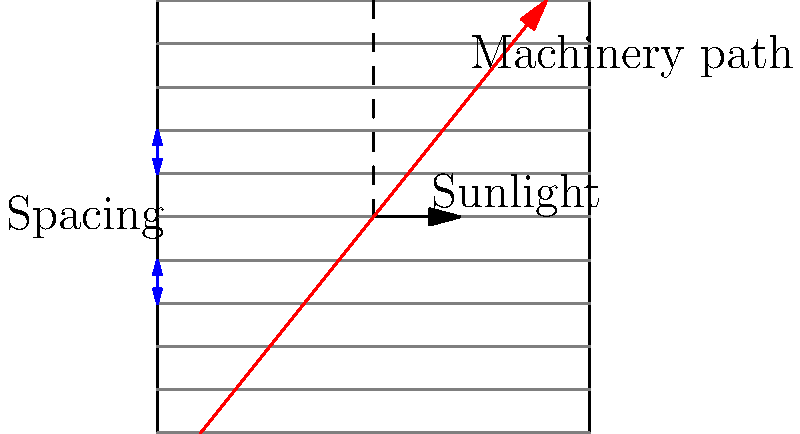In a large-scale commercial farm, you need to optimize the spacing and arrangement of crop rows for maximum sunlight exposure and efficient machinery movement. Given that the average width of your harvesting machinery is 5 meters and the optimal sunlight angle for your crops is 30 degrees from vertical, calculate the ideal row spacing in meters to maximize both sunlight exposure and machinery accessibility. Assume that the field is perfectly flat and that rows run north-south. To solve this problem, we'll follow these steps:

1. Consider the sunlight angle:
   The optimal sunlight angle is 30° from vertical. This means the shadow cast by one row should not reach the next row.

2. Calculate the shadow length:
   Let x be the row height and y be the shadow length.
   $\tan(30°) = \frac{x}{y}$
   $y = x \cdot \cot(30°) = x \cdot \frac{\sqrt{3}}{3}$

3. Determine the minimum row spacing based on sunlight:
   The minimum spacing should be equal to the shadow length.
   $\text{Minimum spacing} = x \cdot \frac{\sqrt{3}}{3}$

4. Consider machinery width:
   The row spacing must also accommodate the 5-meter wide machinery.

5. Choose the larger of the two constraints:
   $\text{Row spacing} = \max(x \cdot \frac{\sqrt{3}}{3}, 5)$

6. Optimize for both constraints:
   Set the shadow length equal to the machinery width:
   $x \cdot \frac{\sqrt{3}}{3} = 5$
   $x = 5 \cdot \frac{3}{\sqrt{3}} \approx 8.66$ meters

7. Calculate the ideal row spacing:
   $\text{Ideal spacing} = 8.66 \cdot \frac{\sqrt{3}}{3} = 5$ meters

This spacing ensures optimal sunlight exposure while allowing the machinery to move between rows efficiently.
Answer: 5 meters 